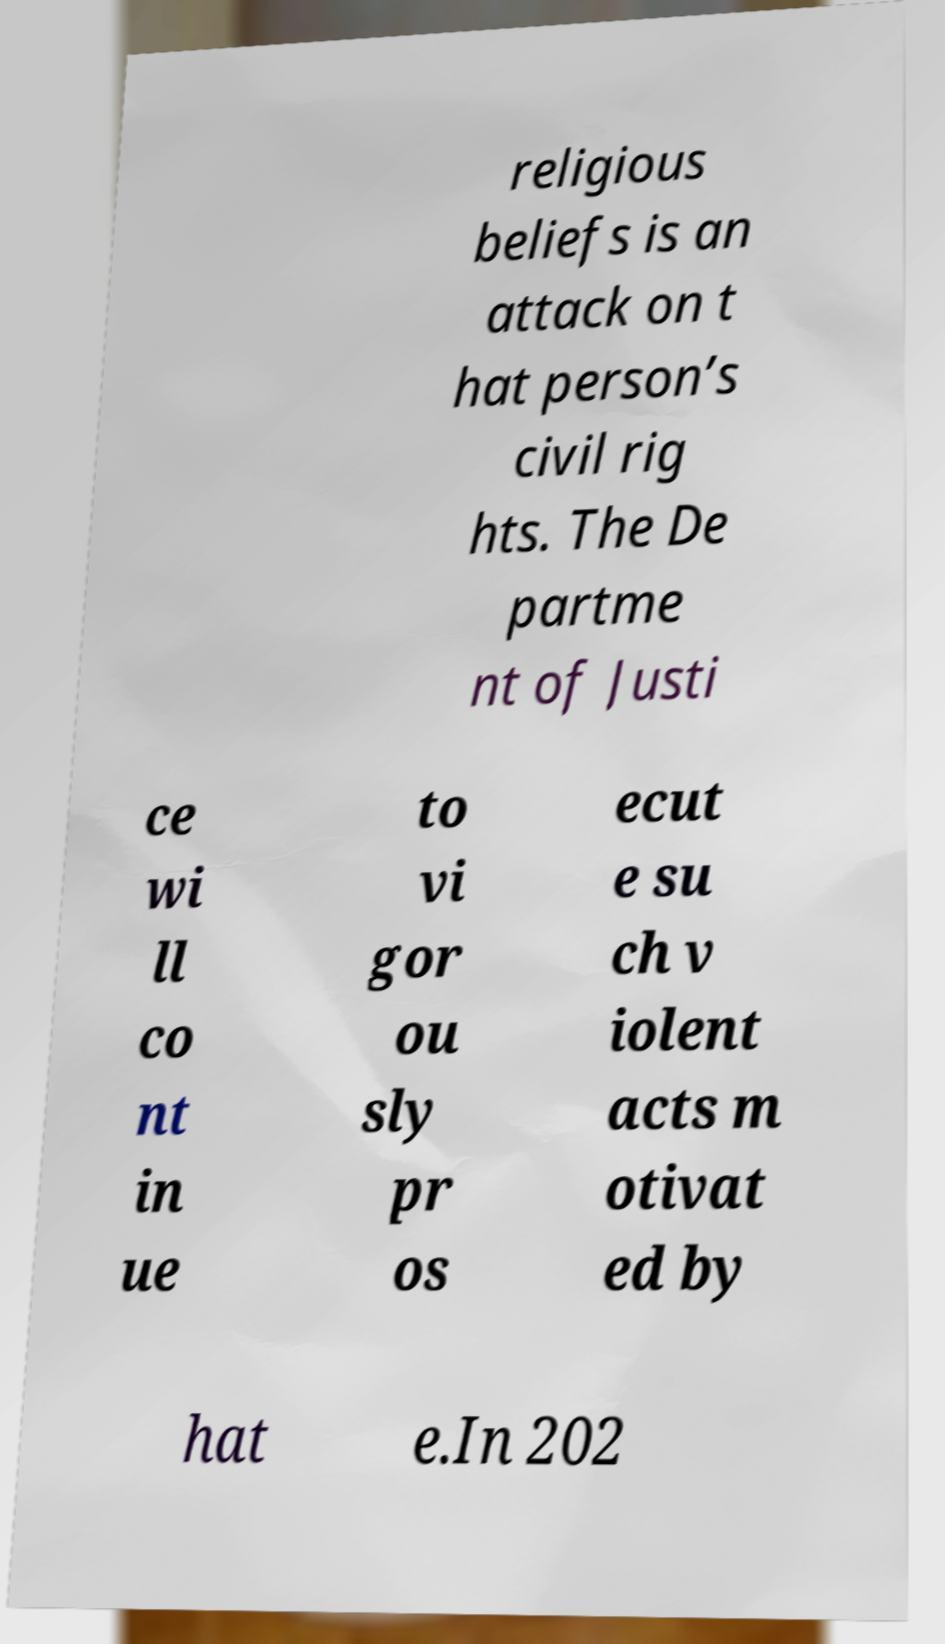Can you accurately transcribe the text from the provided image for me? religious beliefs is an attack on t hat person’s civil rig hts. The De partme nt of Justi ce wi ll co nt in ue to vi gor ou sly pr os ecut e su ch v iolent acts m otivat ed by hat e.In 202 